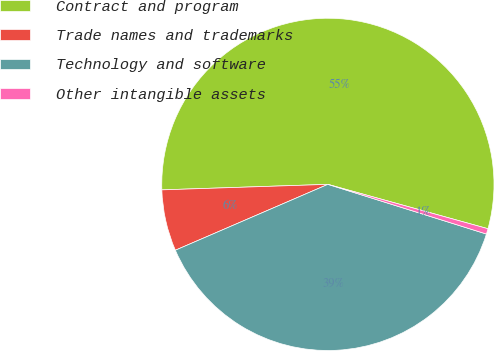Convert chart to OTSL. <chart><loc_0><loc_0><loc_500><loc_500><pie_chart><fcel>Contract and program<fcel>Trade names and trademarks<fcel>Technology and software<fcel>Other intangible assets<nl><fcel>54.83%<fcel>5.96%<fcel>38.68%<fcel>0.53%<nl></chart> 